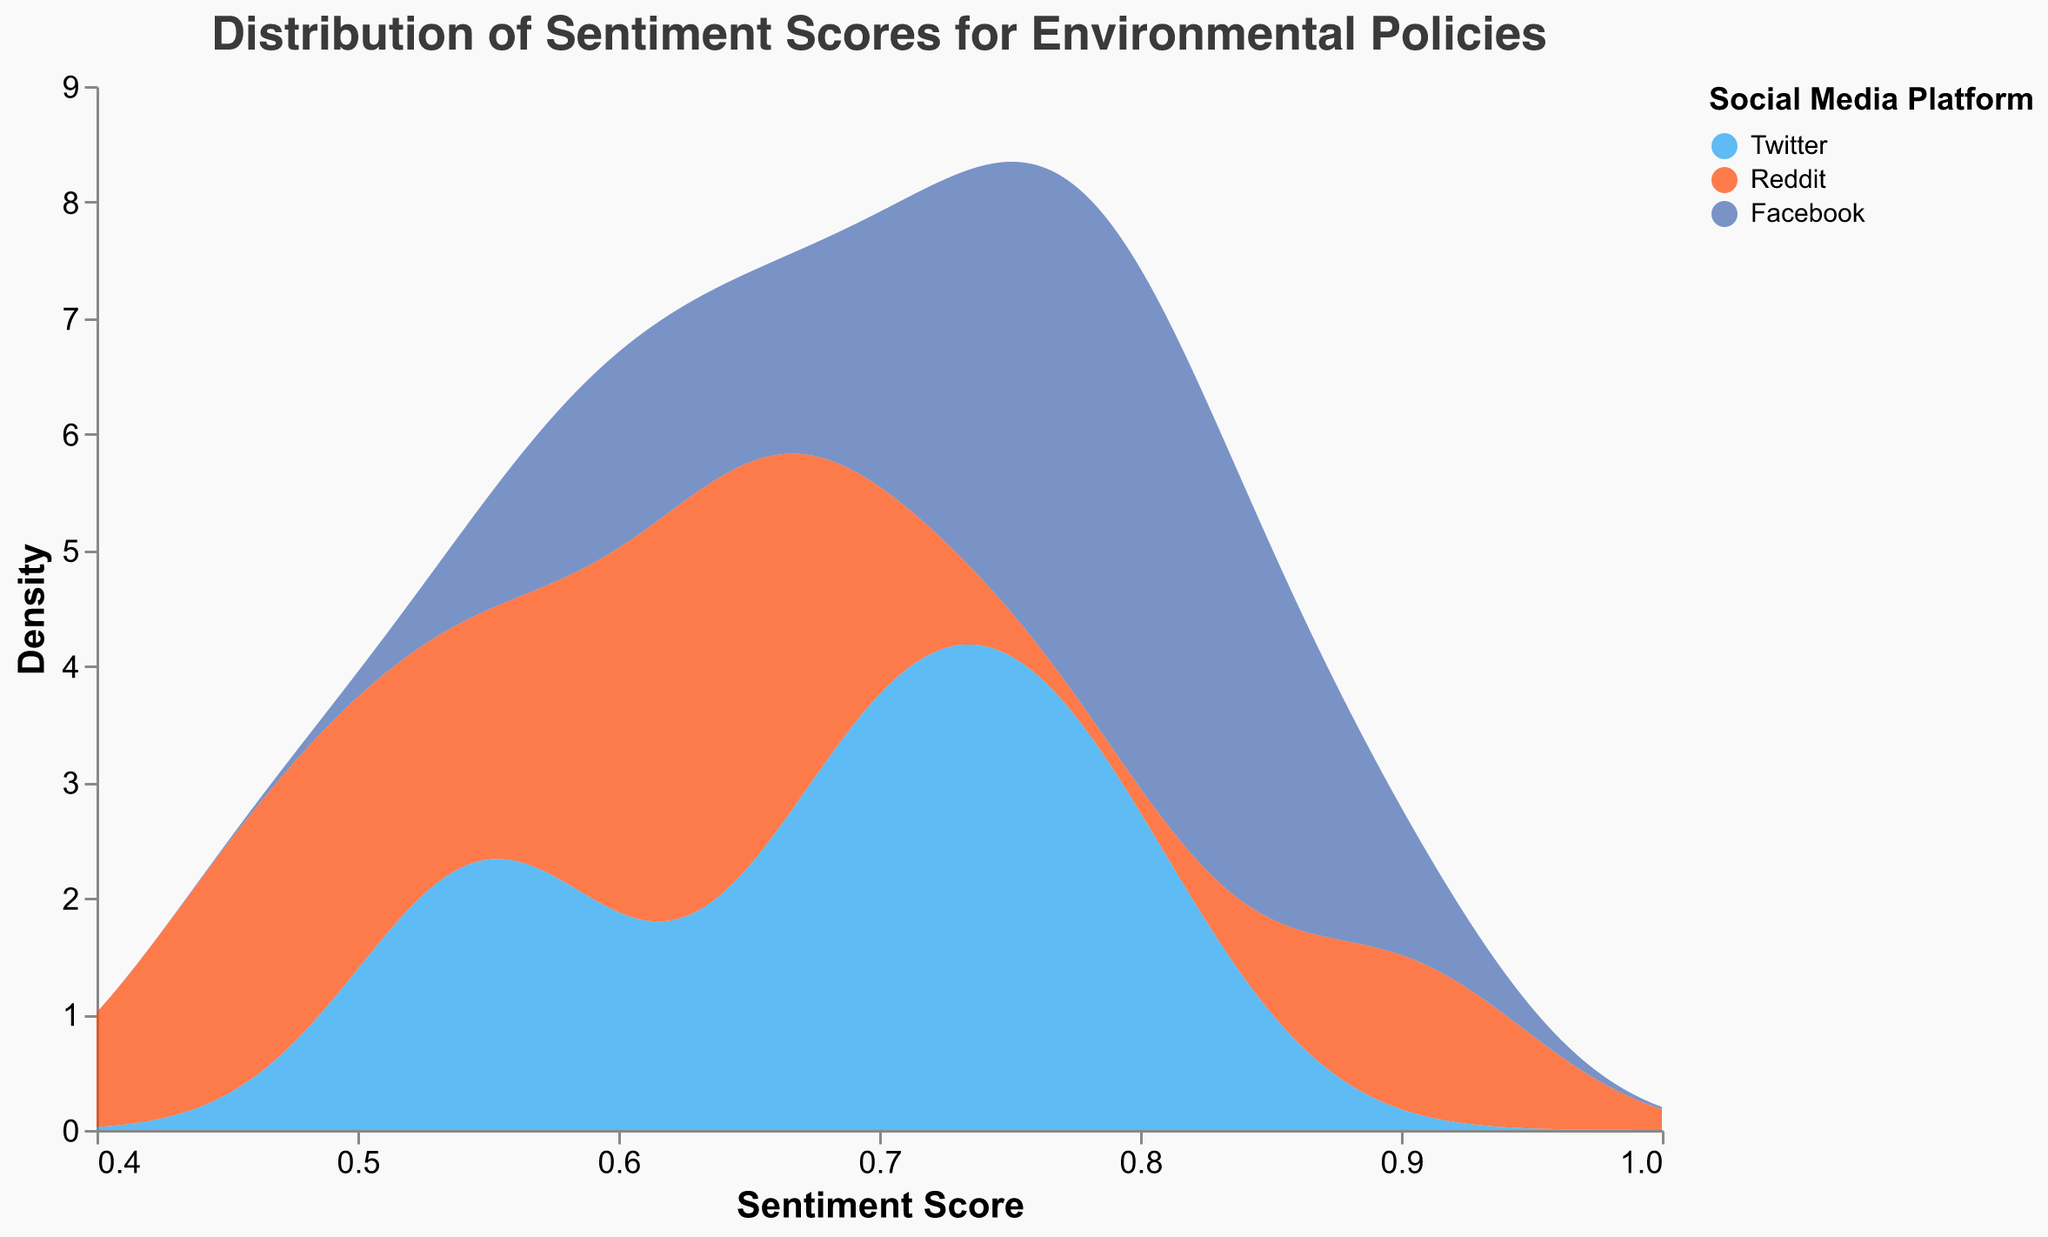What is the title of the figure? The title is usually positioned at the top of the figure, providing a brief description of the visualized data.
Answer: Distribution of Sentiment Scores for Environmental Policies What does the x-axis represent in the figure? The label of the x-axis, typically found below the axis line, identifies the variable being measured.
Answer: Sentiment Score Which social media platform has a peak density value around a sentiment score of 0.70? Observe the color-coded areas around the sentiment score of 0.70 and identify which one has the highest value. The legend indicates platform colors.
Answer: Twitter Which platform shows the widest range of sentiment scores? Check the densities spread along the x-axis for each platform. The platform with the broadest spread across the sentiment scores range has the widest range.
Answer: Facebook What is the color assigned to Twitter in the legend? Refer to the legend which connects each social media platform to a specific color.
Answer: Blue Which platform has the highest peak in sentiment score density? Compare the heights of the peaks in the density plots for each platform. The platform with the highest peak has the highest density.
Answer: Facebook How does the density of Reddit's sentiment scores near 0.90 compare to that of Twitter? Look at the heights of the density areas (the y-axis) mapped to the sentiment score of 0.90 for both Reddit and Twitter.
Answer: Reddit is higher What sentiment score range shows the most overlap among all three platforms? Identify the regions where the colored density areas (representing each platform) overlap the most along the x-axis.
Answer: 0.60 - 0.70 Around which sentiment score does Facebook's density drop sharply? Notice the sharp decline or dip in the area representing Facebook's density. Trace the sentiment score corresponding to this drop.
Answer: Around 0.70 Which platform appears to have the least variation in sentiment scores? Look for the platform with the narrowest spread of density values across the sentiment scores range.
Answer: Reddit 